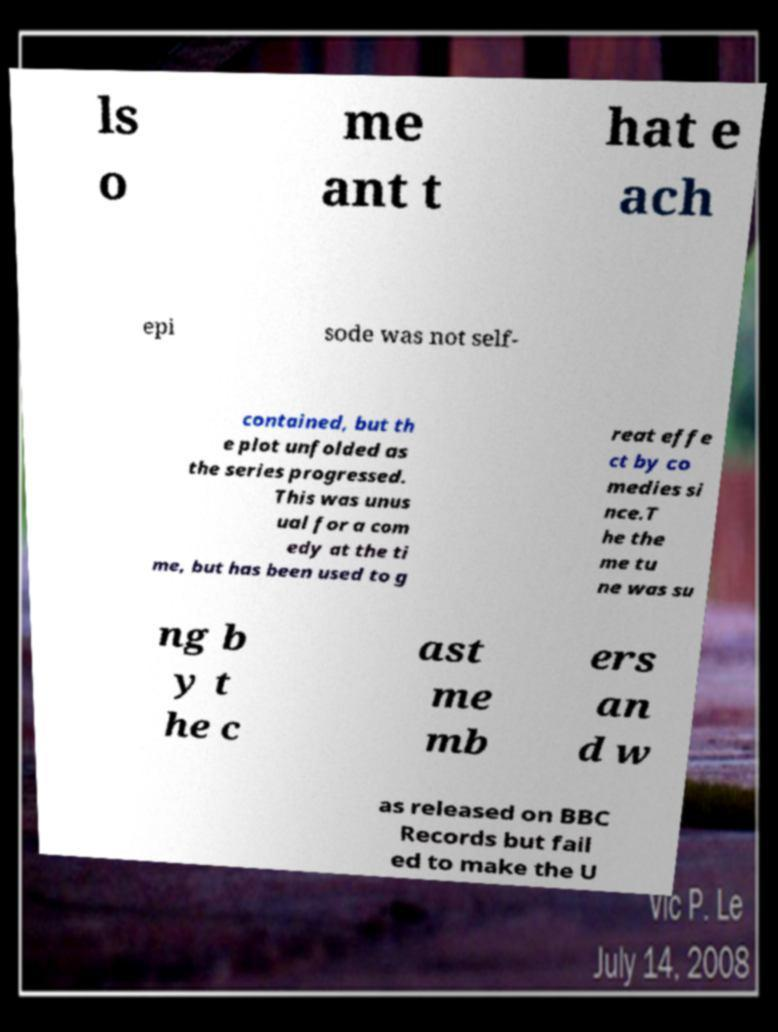There's text embedded in this image that I need extracted. Can you transcribe it verbatim? ls o me ant t hat e ach epi sode was not self- contained, but th e plot unfolded as the series progressed. This was unus ual for a com edy at the ti me, but has been used to g reat effe ct by co medies si nce.T he the me tu ne was su ng b y t he c ast me mb ers an d w as released on BBC Records but fail ed to make the U 